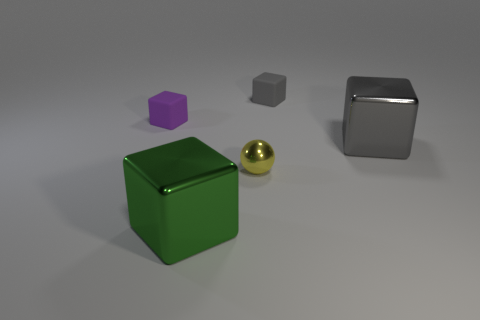What number of cylinders are either tiny gray rubber things or brown rubber objects? In the image provided, there are no objects that resemble cylinders; all objects visible are of solid shapes such as cubes, a sphere, and a hexagonal prism. Additionally, none of these objects appear to be made of rubber, and there are no brown-colored objects present. Therefore, there are zero cylinders that are tiny gray rubber things or brown rubber objects. 